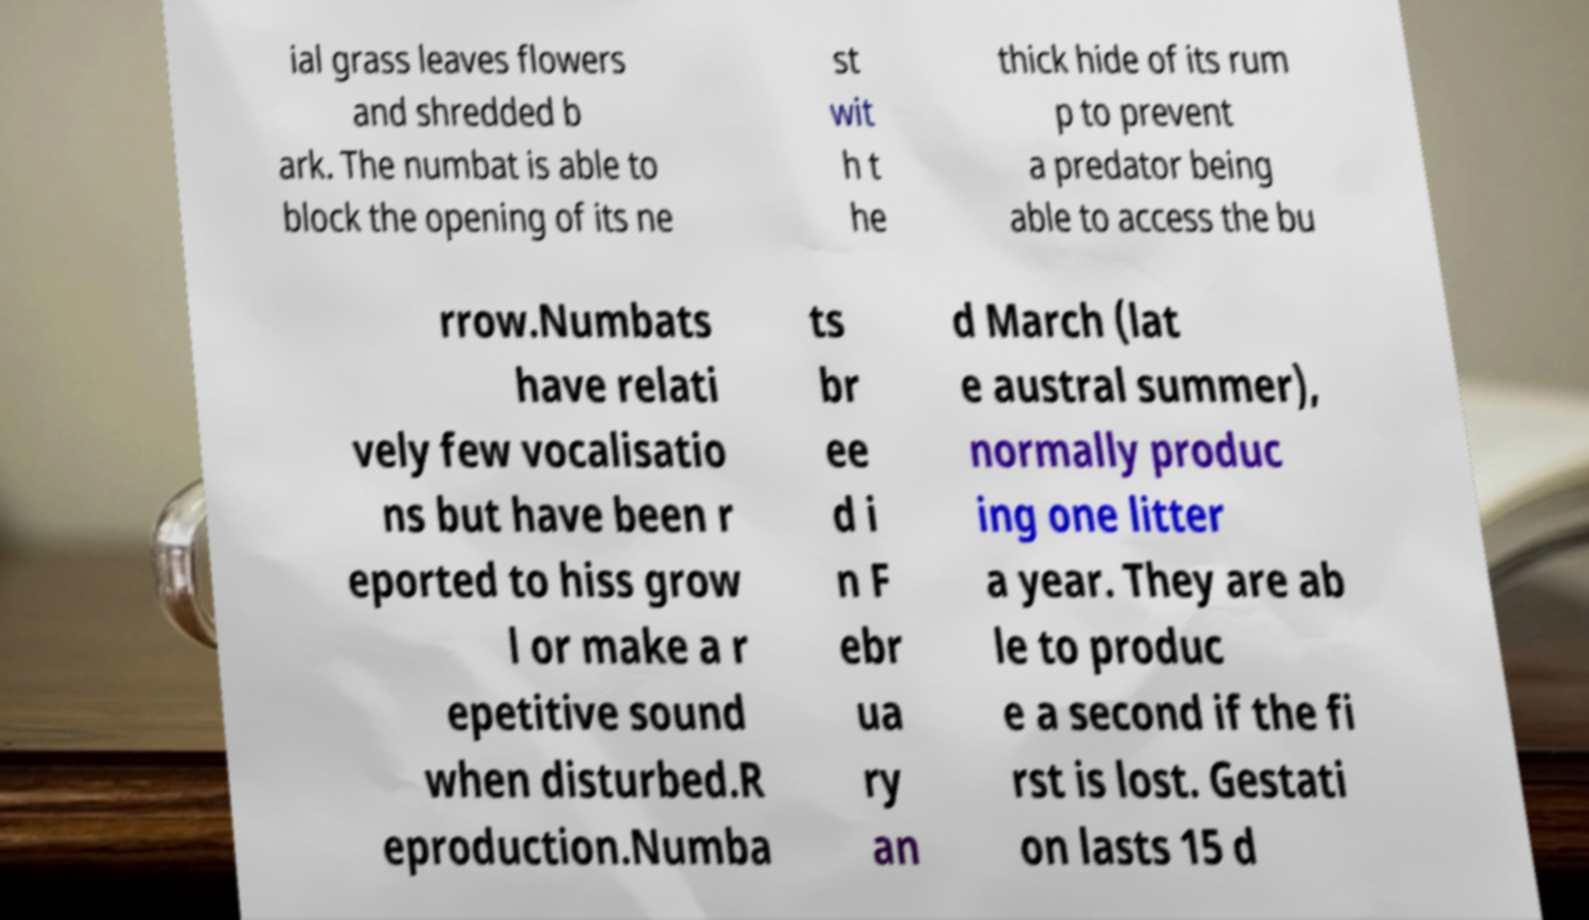Please identify and transcribe the text found in this image. ial grass leaves flowers and shredded b ark. The numbat is able to block the opening of its ne st wit h t he thick hide of its rum p to prevent a predator being able to access the bu rrow.Numbats have relati vely few vocalisatio ns but have been r eported to hiss grow l or make a r epetitive sound when disturbed.R eproduction.Numba ts br ee d i n F ebr ua ry an d March (lat e austral summer), normally produc ing one litter a year. They are ab le to produc e a second if the fi rst is lost. Gestati on lasts 15 d 